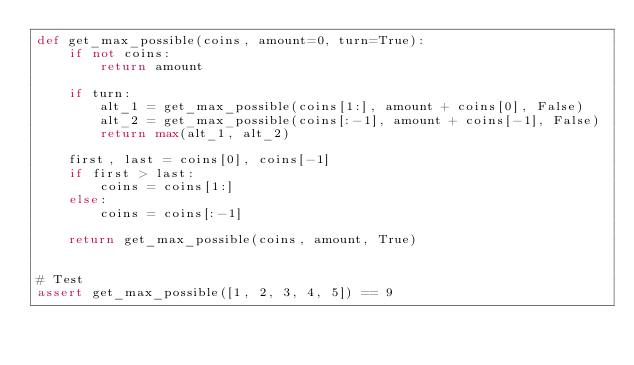<code> <loc_0><loc_0><loc_500><loc_500><_Python_>def get_max_possible(coins, amount=0, turn=True):
    if not coins:
        return amount

    if turn:
        alt_1 = get_max_possible(coins[1:], amount + coins[0], False)
        alt_2 = get_max_possible(coins[:-1], amount + coins[-1], False)
        return max(alt_1, alt_2)

    first, last = coins[0], coins[-1]
    if first > last:
        coins = coins[1:]
    else:
        coins = coins[:-1]

    return get_max_possible(coins, amount, True)


# Test
assert get_max_possible([1, 2, 3, 4, 5]) == 9
</code> 